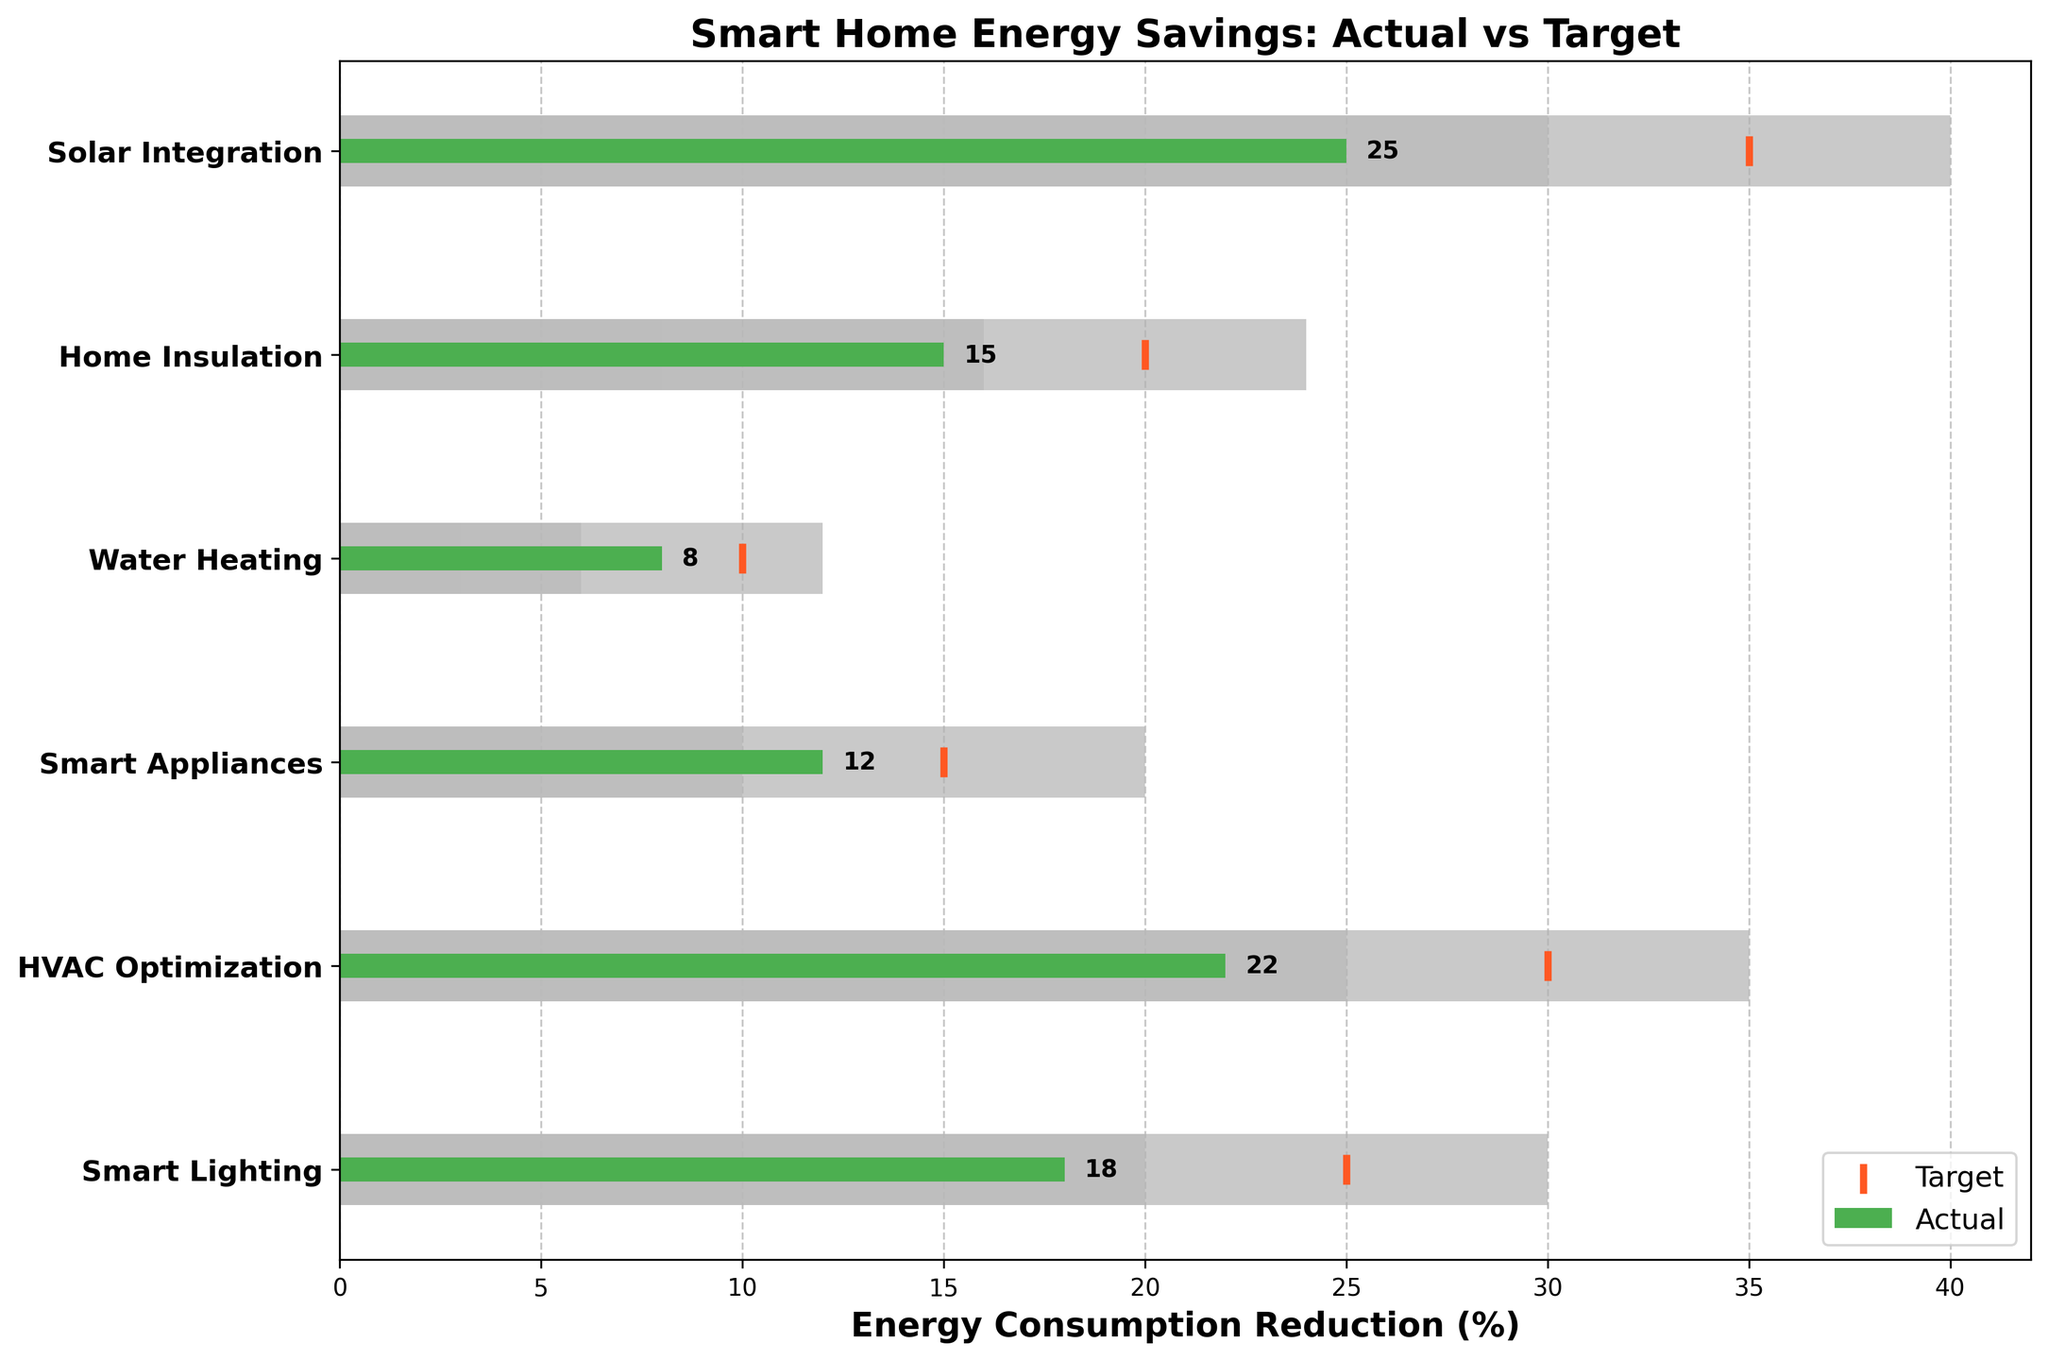What's the title of the chart? The title of the chart is written at the top of the figure and provides an overview of what the chart represents. The chart's title is "Smart Home Energy Savings: Actual vs Target".
Answer: Smart Home Energy Savings: Actual vs Target Which category achieved the highest actual energy consumption reduction? To find this, look for the category with the longest green bar, which represents the actual values. The "Solar Integration" category has the longest green bar.
Answer: Solar Integration What's the target reduction percentage for HVAC Optimization? The target reduction percentage is represented by the orange marker line for HVAC Optimization. The line aligns with the value of 30.
Answer: 30% How much actual reduction did Smart Lighting achieve compared to its target? The actual reduction for Smart Lighting is 18%, and the target is 25%. Subtract the actual from the target: 25 - 18 = 7%.
Answer: 7% Which category fell short by the largest percentage of its target? To find this, compare the difference between the target and actual values for each category. "Solar Integration" fell short by the largest amount: 35 - 25 = 10%.
Answer: Solar Integration How many categories surpassed the first range covered in the chart? First range is the lightest gray section. Examine each category to see if the actual value exceeds the end of the lightest gray section. "Smart Lighting", "HVAC Optimization", "Smart Appliances", and "Solar Integration" surpass it, totaling 4 categories.
Answer: 4 Which category has the smallest difference between actual and target reductions? Calculate the difference between actual and target reductions for each category and compare. The smallest difference is for "Smart Appliances": 15 - 12 = 3%.
Answer: Smart Appliances What range does the category Home Insulation fall into based on its actual reduction? Home Insulation's actual reduction is 15%, which falls within the second range (10-16%) as it exceeds 8% but does not reach 16%.
Answer: Second range Between Smart Appliances and Water Heating, which has a more significant actual reduction? Compare the lengths of the green bars for Smart Appliances (12%) and Water Heating (8%). Smart Appliances has a greater reduction.
Answer: Smart Appliances 